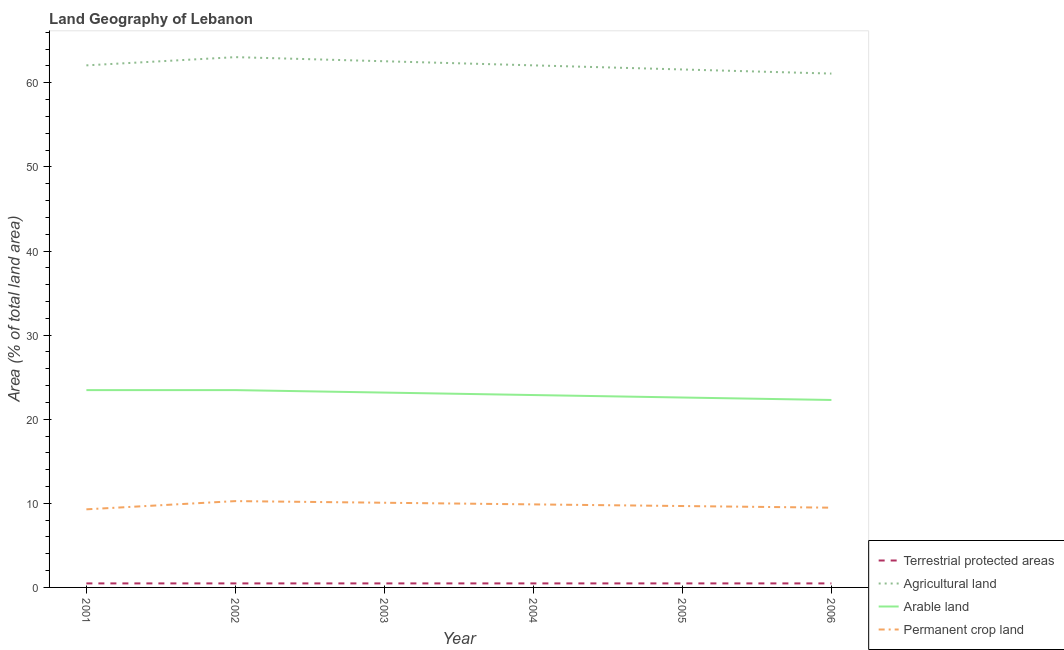How many different coloured lines are there?
Make the answer very short. 4. Does the line corresponding to percentage of area under agricultural land intersect with the line corresponding to percentage of area under permanent crop land?
Your response must be concise. No. Is the number of lines equal to the number of legend labels?
Make the answer very short. Yes. What is the percentage of area under agricultural land in 2001?
Your response must be concise. 62.07. Across all years, what is the maximum percentage of land under terrestrial protection?
Make the answer very short. 0.48. Across all years, what is the minimum percentage of land under terrestrial protection?
Give a very brief answer. 0.48. What is the total percentage of area under permanent crop land in the graph?
Give a very brief answer. 58.65. What is the difference between the percentage of area under arable land in 2002 and that in 2005?
Provide a succinct answer. 0.88. What is the difference between the percentage of area under agricultural land in 2004 and the percentage of area under permanent crop land in 2006?
Provide a short and direct response. 52.59. What is the average percentage of area under permanent crop land per year?
Make the answer very short. 9.78. In the year 2006, what is the difference between the percentage of area under permanent crop land and percentage of area under agricultural land?
Give a very brief answer. -51.61. In how many years, is the percentage of area under arable land greater than 52 %?
Provide a short and direct response. 0. What is the ratio of the percentage of area under agricultural land in 2003 to that in 2005?
Your answer should be very brief. 1.02. Is the difference between the percentage of area under agricultural land in 2003 and 2004 greater than the difference between the percentage of area under permanent crop land in 2003 and 2004?
Offer a terse response. Yes. What is the difference between the highest and the second highest percentage of area under arable land?
Your answer should be compact. 0. What is the difference between the highest and the lowest percentage of area under permanent crop land?
Make the answer very short. 0.98. In how many years, is the percentage of area under permanent crop land greater than the average percentage of area under permanent crop land taken over all years?
Your answer should be very brief. 3. Is the sum of the percentage of area under agricultural land in 2001 and 2002 greater than the maximum percentage of area under permanent crop land across all years?
Offer a very short reply. Yes. Is it the case that in every year, the sum of the percentage of land under terrestrial protection and percentage of area under agricultural land is greater than the percentage of area under arable land?
Ensure brevity in your answer.  Yes. How many lines are there?
Your answer should be compact. 4. What is the difference between two consecutive major ticks on the Y-axis?
Give a very brief answer. 10. Are the values on the major ticks of Y-axis written in scientific E-notation?
Provide a succinct answer. No. Where does the legend appear in the graph?
Your answer should be very brief. Bottom right. What is the title of the graph?
Ensure brevity in your answer.  Land Geography of Lebanon. Does "Methodology assessment" appear as one of the legend labels in the graph?
Make the answer very short. No. What is the label or title of the Y-axis?
Keep it short and to the point. Area (% of total land area). What is the Area (% of total land area) of Terrestrial protected areas in 2001?
Make the answer very short. 0.48. What is the Area (% of total land area) of Agricultural land in 2001?
Your response must be concise. 62.07. What is the Area (% of total land area) in Arable land in 2001?
Offer a terse response. 23.46. What is the Area (% of total land area) of Permanent crop land in 2001?
Offer a very short reply. 9.29. What is the Area (% of total land area) in Terrestrial protected areas in 2002?
Offer a very short reply. 0.48. What is the Area (% of total land area) of Agricultural land in 2002?
Give a very brief answer. 63.05. What is the Area (% of total land area) of Arable land in 2002?
Give a very brief answer. 23.46. What is the Area (% of total land area) of Permanent crop land in 2002?
Your answer should be compact. 10.26. What is the Area (% of total land area) in Terrestrial protected areas in 2003?
Offer a terse response. 0.48. What is the Area (% of total land area) in Agricultural land in 2003?
Offer a terse response. 62.56. What is the Area (% of total land area) of Arable land in 2003?
Give a very brief answer. 23.17. What is the Area (% of total land area) in Permanent crop land in 2003?
Keep it short and to the point. 10.07. What is the Area (% of total land area) of Terrestrial protected areas in 2004?
Your response must be concise. 0.48. What is the Area (% of total land area) of Agricultural land in 2004?
Your answer should be very brief. 62.07. What is the Area (% of total land area) of Arable land in 2004?
Your answer should be compact. 22.87. What is the Area (% of total land area) in Permanent crop land in 2004?
Make the answer very short. 9.87. What is the Area (% of total land area) in Terrestrial protected areas in 2005?
Provide a short and direct response. 0.48. What is the Area (% of total land area) in Agricultural land in 2005?
Provide a succinct answer. 61.58. What is the Area (% of total land area) in Arable land in 2005?
Ensure brevity in your answer.  22.58. What is the Area (% of total land area) of Permanent crop land in 2005?
Your response must be concise. 9.68. What is the Area (% of total land area) of Terrestrial protected areas in 2006?
Give a very brief answer. 0.48. What is the Area (% of total land area) of Agricultural land in 2006?
Your answer should be compact. 61.09. What is the Area (% of total land area) in Arable land in 2006?
Your answer should be very brief. 22.29. What is the Area (% of total land area) of Permanent crop land in 2006?
Ensure brevity in your answer.  9.48. Across all years, what is the maximum Area (% of total land area) in Terrestrial protected areas?
Make the answer very short. 0.48. Across all years, what is the maximum Area (% of total land area) of Agricultural land?
Offer a terse response. 63.05. Across all years, what is the maximum Area (% of total land area) of Arable land?
Your answer should be very brief. 23.46. Across all years, what is the maximum Area (% of total land area) of Permanent crop land?
Offer a terse response. 10.26. Across all years, what is the minimum Area (% of total land area) in Terrestrial protected areas?
Your response must be concise. 0.48. Across all years, what is the minimum Area (% of total land area) of Agricultural land?
Offer a terse response. 61.09. Across all years, what is the minimum Area (% of total land area) of Arable land?
Make the answer very short. 22.29. Across all years, what is the minimum Area (% of total land area) of Permanent crop land?
Your answer should be compact. 9.29. What is the total Area (% of total land area) of Terrestrial protected areas in the graph?
Give a very brief answer. 2.86. What is the total Area (% of total land area) in Agricultural land in the graph?
Give a very brief answer. 372.43. What is the total Area (% of total land area) in Arable land in the graph?
Ensure brevity in your answer.  137.83. What is the total Area (% of total land area) of Permanent crop land in the graph?
Your answer should be very brief. 58.65. What is the difference between the Area (% of total land area) of Terrestrial protected areas in 2001 and that in 2002?
Make the answer very short. 0. What is the difference between the Area (% of total land area) in Agricultural land in 2001 and that in 2002?
Your response must be concise. -0.98. What is the difference between the Area (% of total land area) of Permanent crop land in 2001 and that in 2002?
Provide a succinct answer. -0.98. What is the difference between the Area (% of total land area) in Terrestrial protected areas in 2001 and that in 2003?
Your answer should be compact. 0. What is the difference between the Area (% of total land area) of Agricultural land in 2001 and that in 2003?
Make the answer very short. -0.49. What is the difference between the Area (% of total land area) in Arable land in 2001 and that in 2003?
Give a very brief answer. 0.29. What is the difference between the Area (% of total land area) of Permanent crop land in 2001 and that in 2003?
Offer a terse response. -0.78. What is the difference between the Area (% of total land area) in Terrestrial protected areas in 2001 and that in 2004?
Give a very brief answer. 0. What is the difference between the Area (% of total land area) in Arable land in 2001 and that in 2004?
Offer a very short reply. 0.59. What is the difference between the Area (% of total land area) in Permanent crop land in 2001 and that in 2004?
Keep it short and to the point. -0.59. What is the difference between the Area (% of total land area) in Agricultural land in 2001 and that in 2005?
Offer a very short reply. 0.49. What is the difference between the Area (% of total land area) of Arable land in 2001 and that in 2005?
Provide a succinct answer. 0.88. What is the difference between the Area (% of total land area) in Permanent crop land in 2001 and that in 2005?
Offer a very short reply. -0.39. What is the difference between the Area (% of total land area) in Agricultural land in 2001 and that in 2006?
Make the answer very short. 0.98. What is the difference between the Area (% of total land area) of Arable land in 2001 and that in 2006?
Keep it short and to the point. 1.17. What is the difference between the Area (% of total land area) in Permanent crop land in 2001 and that in 2006?
Provide a short and direct response. -0.2. What is the difference between the Area (% of total land area) in Terrestrial protected areas in 2002 and that in 2003?
Make the answer very short. 0. What is the difference between the Area (% of total land area) in Agricultural land in 2002 and that in 2003?
Provide a succinct answer. 0.49. What is the difference between the Area (% of total land area) in Arable land in 2002 and that in 2003?
Make the answer very short. 0.29. What is the difference between the Area (% of total land area) in Permanent crop land in 2002 and that in 2003?
Provide a succinct answer. 0.2. What is the difference between the Area (% of total land area) of Terrestrial protected areas in 2002 and that in 2004?
Your response must be concise. 0. What is the difference between the Area (% of total land area) in Agricultural land in 2002 and that in 2004?
Give a very brief answer. 0.98. What is the difference between the Area (% of total land area) of Arable land in 2002 and that in 2004?
Your answer should be very brief. 0.59. What is the difference between the Area (% of total land area) of Permanent crop land in 2002 and that in 2004?
Offer a very short reply. 0.39. What is the difference between the Area (% of total land area) of Agricultural land in 2002 and that in 2005?
Make the answer very short. 1.47. What is the difference between the Area (% of total land area) of Arable land in 2002 and that in 2005?
Your answer should be very brief. 0.88. What is the difference between the Area (% of total land area) in Permanent crop land in 2002 and that in 2005?
Offer a terse response. 0.59. What is the difference between the Area (% of total land area) in Agricultural land in 2002 and that in 2006?
Provide a succinct answer. 1.96. What is the difference between the Area (% of total land area) in Arable land in 2002 and that in 2006?
Offer a very short reply. 1.17. What is the difference between the Area (% of total land area) in Permanent crop land in 2002 and that in 2006?
Your answer should be very brief. 0.78. What is the difference between the Area (% of total land area) in Terrestrial protected areas in 2003 and that in 2004?
Provide a succinct answer. 0. What is the difference between the Area (% of total land area) of Agricultural land in 2003 and that in 2004?
Provide a short and direct response. 0.49. What is the difference between the Area (% of total land area) in Arable land in 2003 and that in 2004?
Offer a very short reply. 0.29. What is the difference between the Area (% of total land area) of Permanent crop land in 2003 and that in 2004?
Your response must be concise. 0.2. What is the difference between the Area (% of total land area) of Terrestrial protected areas in 2003 and that in 2005?
Offer a terse response. 0. What is the difference between the Area (% of total land area) of Agricultural land in 2003 and that in 2005?
Ensure brevity in your answer.  0.98. What is the difference between the Area (% of total land area) of Arable land in 2003 and that in 2005?
Provide a short and direct response. 0.59. What is the difference between the Area (% of total land area) of Permanent crop land in 2003 and that in 2005?
Keep it short and to the point. 0.39. What is the difference between the Area (% of total land area) in Terrestrial protected areas in 2003 and that in 2006?
Offer a terse response. 0. What is the difference between the Area (% of total land area) in Agricultural land in 2003 and that in 2006?
Offer a very short reply. 1.47. What is the difference between the Area (% of total land area) in Arable land in 2003 and that in 2006?
Keep it short and to the point. 0.88. What is the difference between the Area (% of total land area) of Permanent crop land in 2003 and that in 2006?
Your response must be concise. 0.59. What is the difference between the Area (% of total land area) of Agricultural land in 2004 and that in 2005?
Make the answer very short. 0.49. What is the difference between the Area (% of total land area) in Arable land in 2004 and that in 2005?
Your answer should be very brief. 0.29. What is the difference between the Area (% of total land area) in Permanent crop land in 2004 and that in 2005?
Ensure brevity in your answer.  0.2. What is the difference between the Area (% of total land area) of Agricultural land in 2004 and that in 2006?
Give a very brief answer. 0.98. What is the difference between the Area (% of total land area) of Arable land in 2004 and that in 2006?
Provide a short and direct response. 0.59. What is the difference between the Area (% of total land area) of Permanent crop land in 2004 and that in 2006?
Provide a succinct answer. 0.39. What is the difference between the Area (% of total land area) in Terrestrial protected areas in 2005 and that in 2006?
Ensure brevity in your answer.  0. What is the difference between the Area (% of total land area) of Agricultural land in 2005 and that in 2006?
Keep it short and to the point. 0.49. What is the difference between the Area (% of total land area) in Arable land in 2005 and that in 2006?
Keep it short and to the point. 0.29. What is the difference between the Area (% of total land area) in Permanent crop land in 2005 and that in 2006?
Your response must be concise. 0.2. What is the difference between the Area (% of total land area) of Terrestrial protected areas in 2001 and the Area (% of total land area) of Agricultural land in 2002?
Provide a short and direct response. -62.57. What is the difference between the Area (% of total land area) of Terrestrial protected areas in 2001 and the Area (% of total land area) of Arable land in 2002?
Your answer should be very brief. -22.98. What is the difference between the Area (% of total land area) of Terrestrial protected areas in 2001 and the Area (% of total land area) of Permanent crop land in 2002?
Your answer should be very brief. -9.79. What is the difference between the Area (% of total land area) in Agricultural land in 2001 and the Area (% of total land area) in Arable land in 2002?
Provide a succinct answer. 38.61. What is the difference between the Area (% of total land area) in Agricultural land in 2001 and the Area (% of total land area) in Permanent crop land in 2002?
Provide a succinct answer. 51.81. What is the difference between the Area (% of total land area) in Arable land in 2001 and the Area (% of total land area) in Permanent crop land in 2002?
Your answer should be very brief. 13.2. What is the difference between the Area (% of total land area) in Terrestrial protected areas in 2001 and the Area (% of total land area) in Agricultural land in 2003?
Your answer should be very brief. -62.08. What is the difference between the Area (% of total land area) in Terrestrial protected areas in 2001 and the Area (% of total land area) in Arable land in 2003?
Ensure brevity in your answer.  -22.69. What is the difference between the Area (% of total land area) in Terrestrial protected areas in 2001 and the Area (% of total land area) in Permanent crop land in 2003?
Ensure brevity in your answer.  -9.59. What is the difference between the Area (% of total land area) in Agricultural land in 2001 and the Area (% of total land area) in Arable land in 2003?
Give a very brief answer. 38.91. What is the difference between the Area (% of total land area) in Agricultural land in 2001 and the Area (% of total land area) in Permanent crop land in 2003?
Your answer should be very brief. 52. What is the difference between the Area (% of total land area) in Arable land in 2001 and the Area (% of total land area) in Permanent crop land in 2003?
Offer a very short reply. 13.39. What is the difference between the Area (% of total land area) of Terrestrial protected areas in 2001 and the Area (% of total land area) of Agricultural land in 2004?
Your answer should be compact. -61.59. What is the difference between the Area (% of total land area) of Terrestrial protected areas in 2001 and the Area (% of total land area) of Arable land in 2004?
Your response must be concise. -22.4. What is the difference between the Area (% of total land area) in Terrestrial protected areas in 2001 and the Area (% of total land area) in Permanent crop land in 2004?
Your answer should be very brief. -9.4. What is the difference between the Area (% of total land area) in Agricultural land in 2001 and the Area (% of total land area) in Arable land in 2004?
Make the answer very short. 39.2. What is the difference between the Area (% of total land area) of Agricultural land in 2001 and the Area (% of total land area) of Permanent crop land in 2004?
Offer a terse response. 52.2. What is the difference between the Area (% of total land area) of Arable land in 2001 and the Area (% of total land area) of Permanent crop land in 2004?
Your answer should be compact. 13.59. What is the difference between the Area (% of total land area) of Terrestrial protected areas in 2001 and the Area (% of total land area) of Agricultural land in 2005?
Provide a short and direct response. -61.11. What is the difference between the Area (% of total land area) of Terrestrial protected areas in 2001 and the Area (% of total land area) of Arable land in 2005?
Your response must be concise. -22.1. What is the difference between the Area (% of total land area) of Terrestrial protected areas in 2001 and the Area (% of total land area) of Permanent crop land in 2005?
Keep it short and to the point. -9.2. What is the difference between the Area (% of total land area) in Agricultural land in 2001 and the Area (% of total land area) in Arable land in 2005?
Ensure brevity in your answer.  39.49. What is the difference between the Area (% of total land area) of Agricultural land in 2001 and the Area (% of total land area) of Permanent crop land in 2005?
Your answer should be very brief. 52.39. What is the difference between the Area (% of total land area) of Arable land in 2001 and the Area (% of total land area) of Permanent crop land in 2005?
Your response must be concise. 13.78. What is the difference between the Area (% of total land area) of Terrestrial protected areas in 2001 and the Area (% of total land area) of Agricultural land in 2006?
Keep it short and to the point. -60.62. What is the difference between the Area (% of total land area) in Terrestrial protected areas in 2001 and the Area (% of total land area) in Arable land in 2006?
Provide a short and direct response. -21.81. What is the difference between the Area (% of total land area) in Terrestrial protected areas in 2001 and the Area (% of total land area) in Permanent crop land in 2006?
Your response must be concise. -9. What is the difference between the Area (% of total land area) in Agricultural land in 2001 and the Area (% of total land area) in Arable land in 2006?
Provide a short and direct response. 39.78. What is the difference between the Area (% of total land area) of Agricultural land in 2001 and the Area (% of total land area) of Permanent crop land in 2006?
Offer a terse response. 52.59. What is the difference between the Area (% of total land area) of Arable land in 2001 and the Area (% of total land area) of Permanent crop land in 2006?
Your answer should be compact. 13.98. What is the difference between the Area (% of total land area) in Terrestrial protected areas in 2002 and the Area (% of total land area) in Agricultural land in 2003?
Provide a succinct answer. -62.08. What is the difference between the Area (% of total land area) in Terrestrial protected areas in 2002 and the Area (% of total land area) in Arable land in 2003?
Offer a very short reply. -22.69. What is the difference between the Area (% of total land area) of Terrestrial protected areas in 2002 and the Area (% of total land area) of Permanent crop land in 2003?
Keep it short and to the point. -9.59. What is the difference between the Area (% of total land area) of Agricultural land in 2002 and the Area (% of total land area) of Arable land in 2003?
Make the answer very short. 39.88. What is the difference between the Area (% of total land area) of Agricultural land in 2002 and the Area (% of total land area) of Permanent crop land in 2003?
Provide a short and direct response. 52.98. What is the difference between the Area (% of total land area) in Arable land in 2002 and the Area (% of total land area) in Permanent crop land in 2003?
Ensure brevity in your answer.  13.39. What is the difference between the Area (% of total land area) in Terrestrial protected areas in 2002 and the Area (% of total land area) in Agricultural land in 2004?
Your answer should be very brief. -61.59. What is the difference between the Area (% of total land area) in Terrestrial protected areas in 2002 and the Area (% of total land area) in Arable land in 2004?
Your answer should be very brief. -22.4. What is the difference between the Area (% of total land area) in Terrestrial protected areas in 2002 and the Area (% of total land area) in Permanent crop land in 2004?
Make the answer very short. -9.4. What is the difference between the Area (% of total land area) in Agricultural land in 2002 and the Area (% of total land area) in Arable land in 2004?
Give a very brief answer. 40.18. What is the difference between the Area (% of total land area) in Agricultural land in 2002 and the Area (% of total land area) in Permanent crop land in 2004?
Offer a terse response. 53.18. What is the difference between the Area (% of total land area) in Arable land in 2002 and the Area (% of total land area) in Permanent crop land in 2004?
Keep it short and to the point. 13.59. What is the difference between the Area (% of total land area) of Terrestrial protected areas in 2002 and the Area (% of total land area) of Agricultural land in 2005?
Ensure brevity in your answer.  -61.11. What is the difference between the Area (% of total land area) of Terrestrial protected areas in 2002 and the Area (% of total land area) of Arable land in 2005?
Make the answer very short. -22.1. What is the difference between the Area (% of total land area) of Terrestrial protected areas in 2002 and the Area (% of total land area) of Permanent crop land in 2005?
Ensure brevity in your answer.  -9.2. What is the difference between the Area (% of total land area) in Agricultural land in 2002 and the Area (% of total land area) in Arable land in 2005?
Your answer should be very brief. 40.47. What is the difference between the Area (% of total land area) of Agricultural land in 2002 and the Area (% of total land area) of Permanent crop land in 2005?
Give a very brief answer. 53.37. What is the difference between the Area (% of total land area) in Arable land in 2002 and the Area (% of total land area) in Permanent crop land in 2005?
Offer a very short reply. 13.78. What is the difference between the Area (% of total land area) of Terrestrial protected areas in 2002 and the Area (% of total land area) of Agricultural land in 2006?
Ensure brevity in your answer.  -60.62. What is the difference between the Area (% of total land area) of Terrestrial protected areas in 2002 and the Area (% of total land area) of Arable land in 2006?
Offer a terse response. -21.81. What is the difference between the Area (% of total land area) in Terrestrial protected areas in 2002 and the Area (% of total land area) in Permanent crop land in 2006?
Keep it short and to the point. -9. What is the difference between the Area (% of total land area) in Agricultural land in 2002 and the Area (% of total land area) in Arable land in 2006?
Give a very brief answer. 40.76. What is the difference between the Area (% of total land area) in Agricultural land in 2002 and the Area (% of total land area) in Permanent crop land in 2006?
Provide a succinct answer. 53.57. What is the difference between the Area (% of total land area) in Arable land in 2002 and the Area (% of total land area) in Permanent crop land in 2006?
Your answer should be very brief. 13.98. What is the difference between the Area (% of total land area) in Terrestrial protected areas in 2003 and the Area (% of total land area) in Agricultural land in 2004?
Provide a short and direct response. -61.59. What is the difference between the Area (% of total land area) in Terrestrial protected areas in 2003 and the Area (% of total land area) in Arable land in 2004?
Your response must be concise. -22.4. What is the difference between the Area (% of total land area) of Terrestrial protected areas in 2003 and the Area (% of total land area) of Permanent crop land in 2004?
Your response must be concise. -9.4. What is the difference between the Area (% of total land area) in Agricultural land in 2003 and the Area (% of total land area) in Arable land in 2004?
Make the answer very short. 39.69. What is the difference between the Area (% of total land area) of Agricultural land in 2003 and the Area (% of total land area) of Permanent crop land in 2004?
Give a very brief answer. 52.69. What is the difference between the Area (% of total land area) in Arable land in 2003 and the Area (% of total land area) in Permanent crop land in 2004?
Offer a very short reply. 13.29. What is the difference between the Area (% of total land area) of Terrestrial protected areas in 2003 and the Area (% of total land area) of Agricultural land in 2005?
Provide a short and direct response. -61.11. What is the difference between the Area (% of total land area) in Terrestrial protected areas in 2003 and the Area (% of total land area) in Arable land in 2005?
Your answer should be very brief. -22.1. What is the difference between the Area (% of total land area) of Terrestrial protected areas in 2003 and the Area (% of total land area) of Permanent crop land in 2005?
Your answer should be very brief. -9.2. What is the difference between the Area (% of total land area) in Agricultural land in 2003 and the Area (% of total land area) in Arable land in 2005?
Your answer should be compact. 39.98. What is the difference between the Area (% of total land area) of Agricultural land in 2003 and the Area (% of total land area) of Permanent crop land in 2005?
Ensure brevity in your answer.  52.88. What is the difference between the Area (% of total land area) in Arable land in 2003 and the Area (% of total land area) in Permanent crop land in 2005?
Your answer should be very brief. 13.49. What is the difference between the Area (% of total land area) of Terrestrial protected areas in 2003 and the Area (% of total land area) of Agricultural land in 2006?
Keep it short and to the point. -60.62. What is the difference between the Area (% of total land area) in Terrestrial protected areas in 2003 and the Area (% of total land area) in Arable land in 2006?
Keep it short and to the point. -21.81. What is the difference between the Area (% of total land area) of Terrestrial protected areas in 2003 and the Area (% of total land area) of Permanent crop land in 2006?
Keep it short and to the point. -9. What is the difference between the Area (% of total land area) in Agricultural land in 2003 and the Area (% of total land area) in Arable land in 2006?
Provide a short and direct response. 40.27. What is the difference between the Area (% of total land area) of Agricultural land in 2003 and the Area (% of total land area) of Permanent crop land in 2006?
Give a very brief answer. 53.08. What is the difference between the Area (% of total land area) in Arable land in 2003 and the Area (% of total land area) in Permanent crop land in 2006?
Offer a terse response. 13.69. What is the difference between the Area (% of total land area) of Terrestrial protected areas in 2004 and the Area (% of total land area) of Agricultural land in 2005?
Give a very brief answer. -61.11. What is the difference between the Area (% of total land area) in Terrestrial protected areas in 2004 and the Area (% of total land area) in Arable land in 2005?
Offer a very short reply. -22.1. What is the difference between the Area (% of total land area) of Terrestrial protected areas in 2004 and the Area (% of total land area) of Permanent crop land in 2005?
Provide a short and direct response. -9.2. What is the difference between the Area (% of total land area) in Agricultural land in 2004 and the Area (% of total land area) in Arable land in 2005?
Your answer should be very brief. 39.49. What is the difference between the Area (% of total land area) in Agricultural land in 2004 and the Area (% of total land area) in Permanent crop land in 2005?
Give a very brief answer. 52.39. What is the difference between the Area (% of total land area) of Arable land in 2004 and the Area (% of total land area) of Permanent crop land in 2005?
Ensure brevity in your answer.  13.2. What is the difference between the Area (% of total land area) of Terrestrial protected areas in 2004 and the Area (% of total land area) of Agricultural land in 2006?
Provide a short and direct response. -60.62. What is the difference between the Area (% of total land area) of Terrestrial protected areas in 2004 and the Area (% of total land area) of Arable land in 2006?
Provide a succinct answer. -21.81. What is the difference between the Area (% of total land area) in Terrestrial protected areas in 2004 and the Area (% of total land area) in Permanent crop land in 2006?
Provide a short and direct response. -9. What is the difference between the Area (% of total land area) of Agricultural land in 2004 and the Area (% of total land area) of Arable land in 2006?
Provide a succinct answer. 39.78. What is the difference between the Area (% of total land area) in Agricultural land in 2004 and the Area (% of total land area) in Permanent crop land in 2006?
Your response must be concise. 52.59. What is the difference between the Area (% of total land area) of Arable land in 2004 and the Area (% of total land area) of Permanent crop land in 2006?
Give a very brief answer. 13.39. What is the difference between the Area (% of total land area) of Terrestrial protected areas in 2005 and the Area (% of total land area) of Agricultural land in 2006?
Keep it short and to the point. -60.62. What is the difference between the Area (% of total land area) of Terrestrial protected areas in 2005 and the Area (% of total land area) of Arable land in 2006?
Your response must be concise. -21.81. What is the difference between the Area (% of total land area) in Terrestrial protected areas in 2005 and the Area (% of total land area) in Permanent crop land in 2006?
Give a very brief answer. -9. What is the difference between the Area (% of total land area) in Agricultural land in 2005 and the Area (% of total land area) in Arable land in 2006?
Provide a succinct answer. 39.3. What is the difference between the Area (% of total land area) of Agricultural land in 2005 and the Area (% of total land area) of Permanent crop land in 2006?
Provide a succinct answer. 52.1. What is the difference between the Area (% of total land area) of Arable land in 2005 and the Area (% of total land area) of Permanent crop land in 2006?
Your answer should be compact. 13.1. What is the average Area (% of total land area) in Terrestrial protected areas per year?
Make the answer very short. 0.48. What is the average Area (% of total land area) of Agricultural land per year?
Make the answer very short. 62.07. What is the average Area (% of total land area) of Arable land per year?
Provide a short and direct response. 22.97. What is the average Area (% of total land area) in Permanent crop land per year?
Ensure brevity in your answer.  9.78. In the year 2001, what is the difference between the Area (% of total land area) of Terrestrial protected areas and Area (% of total land area) of Agricultural land?
Give a very brief answer. -61.59. In the year 2001, what is the difference between the Area (% of total land area) of Terrestrial protected areas and Area (% of total land area) of Arable land?
Offer a terse response. -22.98. In the year 2001, what is the difference between the Area (% of total land area) of Terrestrial protected areas and Area (% of total land area) of Permanent crop land?
Offer a terse response. -8.81. In the year 2001, what is the difference between the Area (% of total land area) of Agricultural land and Area (% of total land area) of Arable land?
Ensure brevity in your answer.  38.61. In the year 2001, what is the difference between the Area (% of total land area) of Agricultural land and Area (% of total land area) of Permanent crop land?
Your answer should be compact. 52.79. In the year 2001, what is the difference between the Area (% of total land area) of Arable land and Area (% of total land area) of Permanent crop land?
Offer a very short reply. 14.17. In the year 2002, what is the difference between the Area (% of total land area) of Terrestrial protected areas and Area (% of total land area) of Agricultural land?
Provide a succinct answer. -62.57. In the year 2002, what is the difference between the Area (% of total land area) in Terrestrial protected areas and Area (% of total land area) in Arable land?
Your response must be concise. -22.98. In the year 2002, what is the difference between the Area (% of total land area) in Terrestrial protected areas and Area (% of total land area) in Permanent crop land?
Your response must be concise. -9.79. In the year 2002, what is the difference between the Area (% of total land area) in Agricultural land and Area (% of total land area) in Arable land?
Your answer should be compact. 39.59. In the year 2002, what is the difference between the Area (% of total land area) of Agricultural land and Area (% of total land area) of Permanent crop land?
Ensure brevity in your answer.  52.79. In the year 2002, what is the difference between the Area (% of total land area) of Arable land and Area (% of total land area) of Permanent crop land?
Your response must be concise. 13.2. In the year 2003, what is the difference between the Area (% of total land area) in Terrestrial protected areas and Area (% of total land area) in Agricultural land?
Ensure brevity in your answer.  -62.08. In the year 2003, what is the difference between the Area (% of total land area) of Terrestrial protected areas and Area (% of total land area) of Arable land?
Offer a very short reply. -22.69. In the year 2003, what is the difference between the Area (% of total land area) of Terrestrial protected areas and Area (% of total land area) of Permanent crop land?
Make the answer very short. -9.59. In the year 2003, what is the difference between the Area (% of total land area) of Agricultural land and Area (% of total land area) of Arable land?
Make the answer very short. 39.39. In the year 2003, what is the difference between the Area (% of total land area) in Agricultural land and Area (% of total land area) in Permanent crop land?
Provide a short and direct response. 52.49. In the year 2003, what is the difference between the Area (% of total land area) in Arable land and Area (% of total land area) in Permanent crop land?
Your answer should be compact. 13.1. In the year 2004, what is the difference between the Area (% of total land area) of Terrestrial protected areas and Area (% of total land area) of Agricultural land?
Provide a short and direct response. -61.59. In the year 2004, what is the difference between the Area (% of total land area) of Terrestrial protected areas and Area (% of total land area) of Arable land?
Provide a succinct answer. -22.4. In the year 2004, what is the difference between the Area (% of total land area) of Terrestrial protected areas and Area (% of total land area) of Permanent crop land?
Ensure brevity in your answer.  -9.4. In the year 2004, what is the difference between the Area (% of total land area) of Agricultural land and Area (% of total land area) of Arable land?
Give a very brief answer. 39.2. In the year 2004, what is the difference between the Area (% of total land area) in Agricultural land and Area (% of total land area) in Permanent crop land?
Offer a terse response. 52.2. In the year 2004, what is the difference between the Area (% of total land area) in Arable land and Area (% of total land area) in Permanent crop land?
Provide a succinct answer. 13. In the year 2005, what is the difference between the Area (% of total land area) in Terrestrial protected areas and Area (% of total land area) in Agricultural land?
Offer a very short reply. -61.11. In the year 2005, what is the difference between the Area (% of total land area) of Terrestrial protected areas and Area (% of total land area) of Arable land?
Offer a terse response. -22.1. In the year 2005, what is the difference between the Area (% of total land area) in Terrestrial protected areas and Area (% of total land area) in Permanent crop land?
Give a very brief answer. -9.2. In the year 2005, what is the difference between the Area (% of total land area) in Agricultural land and Area (% of total land area) in Arable land?
Your response must be concise. 39. In the year 2005, what is the difference between the Area (% of total land area) in Agricultural land and Area (% of total land area) in Permanent crop land?
Provide a short and direct response. 51.91. In the year 2005, what is the difference between the Area (% of total land area) of Arable land and Area (% of total land area) of Permanent crop land?
Your response must be concise. 12.9. In the year 2006, what is the difference between the Area (% of total land area) of Terrestrial protected areas and Area (% of total land area) of Agricultural land?
Give a very brief answer. -60.62. In the year 2006, what is the difference between the Area (% of total land area) of Terrestrial protected areas and Area (% of total land area) of Arable land?
Provide a short and direct response. -21.81. In the year 2006, what is the difference between the Area (% of total land area) of Terrestrial protected areas and Area (% of total land area) of Permanent crop land?
Make the answer very short. -9. In the year 2006, what is the difference between the Area (% of total land area) of Agricultural land and Area (% of total land area) of Arable land?
Make the answer very short. 38.81. In the year 2006, what is the difference between the Area (% of total land area) of Agricultural land and Area (% of total land area) of Permanent crop land?
Offer a very short reply. 51.61. In the year 2006, what is the difference between the Area (% of total land area) in Arable land and Area (% of total land area) in Permanent crop land?
Ensure brevity in your answer.  12.81. What is the ratio of the Area (% of total land area) of Terrestrial protected areas in 2001 to that in 2002?
Ensure brevity in your answer.  1. What is the ratio of the Area (% of total land area) of Agricultural land in 2001 to that in 2002?
Your answer should be very brief. 0.98. What is the ratio of the Area (% of total land area) of Permanent crop land in 2001 to that in 2002?
Give a very brief answer. 0.9. What is the ratio of the Area (% of total land area) in Agricultural land in 2001 to that in 2003?
Keep it short and to the point. 0.99. What is the ratio of the Area (% of total land area) of Arable land in 2001 to that in 2003?
Provide a succinct answer. 1.01. What is the ratio of the Area (% of total land area) in Permanent crop land in 2001 to that in 2003?
Your answer should be compact. 0.92. What is the ratio of the Area (% of total land area) in Agricultural land in 2001 to that in 2004?
Keep it short and to the point. 1. What is the ratio of the Area (% of total land area) of Arable land in 2001 to that in 2004?
Give a very brief answer. 1.03. What is the ratio of the Area (% of total land area) of Permanent crop land in 2001 to that in 2004?
Make the answer very short. 0.94. What is the ratio of the Area (% of total land area) in Terrestrial protected areas in 2001 to that in 2005?
Give a very brief answer. 1. What is the ratio of the Area (% of total land area) of Agricultural land in 2001 to that in 2005?
Keep it short and to the point. 1.01. What is the ratio of the Area (% of total land area) of Arable land in 2001 to that in 2005?
Offer a terse response. 1.04. What is the ratio of the Area (% of total land area) of Permanent crop land in 2001 to that in 2005?
Your answer should be compact. 0.96. What is the ratio of the Area (% of total land area) in Arable land in 2001 to that in 2006?
Offer a terse response. 1.05. What is the ratio of the Area (% of total land area) in Permanent crop land in 2001 to that in 2006?
Keep it short and to the point. 0.98. What is the ratio of the Area (% of total land area) of Terrestrial protected areas in 2002 to that in 2003?
Provide a succinct answer. 1. What is the ratio of the Area (% of total land area) of Arable land in 2002 to that in 2003?
Your response must be concise. 1.01. What is the ratio of the Area (% of total land area) of Permanent crop land in 2002 to that in 2003?
Offer a very short reply. 1.02. What is the ratio of the Area (% of total land area) of Agricultural land in 2002 to that in 2004?
Ensure brevity in your answer.  1.02. What is the ratio of the Area (% of total land area) of Arable land in 2002 to that in 2004?
Your answer should be very brief. 1.03. What is the ratio of the Area (% of total land area) in Permanent crop land in 2002 to that in 2004?
Your answer should be compact. 1.04. What is the ratio of the Area (% of total land area) in Terrestrial protected areas in 2002 to that in 2005?
Provide a short and direct response. 1. What is the ratio of the Area (% of total land area) in Agricultural land in 2002 to that in 2005?
Your answer should be very brief. 1.02. What is the ratio of the Area (% of total land area) of Arable land in 2002 to that in 2005?
Keep it short and to the point. 1.04. What is the ratio of the Area (% of total land area) in Permanent crop land in 2002 to that in 2005?
Your answer should be very brief. 1.06. What is the ratio of the Area (% of total land area) of Agricultural land in 2002 to that in 2006?
Offer a very short reply. 1.03. What is the ratio of the Area (% of total land area) in Arable land in 2002 to that in 2006?
Offer a terse response. 1.05. What is the ratio of the Area (% of total land area) of Permanent crop land in 2002 to that in 2006?
Provide a short and direct response. 1.08. What is the ratio of the Area (% of total land area) in Terrestrial protected areas in 2003 to that in 2004?
Your response must be concise. 1. What is the ratio of the Area (% of total land area) of Agricultural land in 2003 to that in 2004?
Your answer should be compact. 1.01. What is the ratio of the Area (% of total land area) of Arable land in 2003 to that in 2004?
Give a very brief answer. 1.01. What is the ratio of the Area (% of total land area) in Permanent crop land in 2003 to that in 2004?
Provide a succinct answer. 1.02. What is the ratio of the Area (% of total land area) in Agricultural land in 2003 to that in 2005?
Ensure brevity in your answer.  1.02. What is the ratio of the Area (% of total land area) of Permanent crop land in 2003 to that in 2005?
Give a very brief answer. 1.04. What is the ratio of the Area (% of total land area) of Terrestrial protected areas in 2003 to that in 2006?
Make the answer very short. 1. What is the ratio of the Area (% of total land area) of Arable land in 2003 to that in 2006?
Make the answer very short. 1.04. What is the ratio of the Area (% of total land area) in Permanent crop land in 2003 to that in 2006?
Your answer should be very brief. 1.06. What is the ratio of the Area (% of total land area) in Agricultural land in 2004 to that in 2005?
Your answer should be compact. 1.01. What is the ratio of the Area (% of total land area) in Permanent crop land in 2004 to that in 2005?
Your response must be concise. 1.02. What is the ratio of the Area (% of total land area) in Terrestrial protected areas in 2004 to that in 2006?
Make the answer very short. 1. What is the ratio of the Area (% of total land area) in Arable land in 2004 to that in 2006?
Offer a very short reply. 1.03. What is the ratio of the Area (% of total land area) of Permanent crop land in 2004 to that in 2006?
Your response must be concise. 1.04. What is the ratio of the Area (% of total land area) in Terrestrial protected areas in 2005 to that in 2006?
Provide a short and direct response. 1. What is the ratio of the Area (% of total land area) of Agricultural land in 2005 to that in 2006?
Keep it short and to the point. 1.01. What is the ratio of the Area (% of total land area) of Arable land in 2005 to that in 2006?
Your answer should be very brief. 1.01. What is the ratio of the Area (% of total land area) of Permanent crop land in 2005 to that in 2006?
Offer a terse response. 1.02. What is the difference between the highest and the second highest Area (% of total land area) in Terrestrial protected areas?
Your answer should be very brief. 0. What is the difference between the highest and the second highest Area (% of total land area) of Agricultural land?
Your answer should be compact. 0.49. What is the difference between the highest and the second highest Area (% of total land area) in Arable land?
Offer a very short reply. 0. What is the difference between the highest and the second highest Area (% of total land area) of Permanent crop land?
Provide a succinct answer. 0.2. What is the difference between the highest and the lowest Area (% of total land area) in Agricultural land?
Provide a succinct answer. 1.96. What is the difference between the highest and the lowest Area (% of total land area) in Arable land?
Offer a very short reply. 1.17. What is the difference between the highest and the lowest Area (% of total land area) in Permanent crop land?
Give a very brief answer. 0.98. 